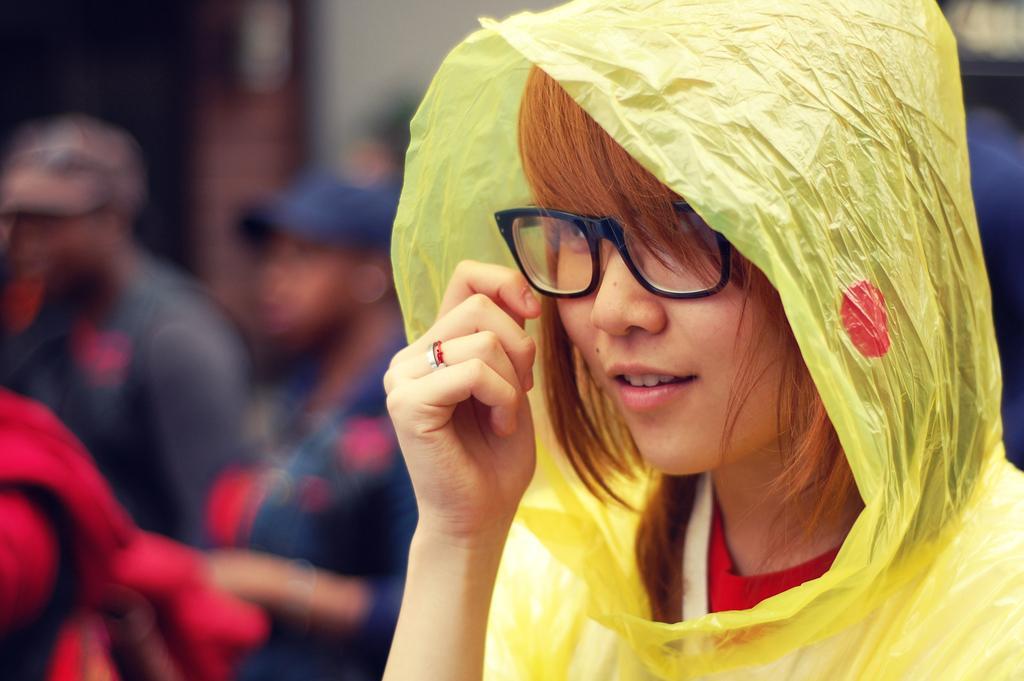Please provide a concise description of this image. In the center of the image we can see one woman smiling, which we can see on her face. And we can see one yellow color plastic cover on her. In the background, we can see a few people are standing and wearing caps and a few other objects. 